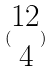<formula> <loc_0><loc_0><loc_500><loc_500>( \begin{matrix} 1 2 \\ 4 \end{matrix} )</formula> 